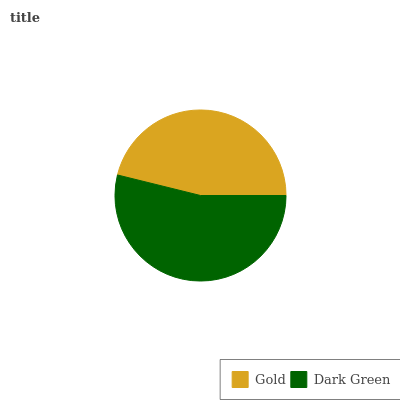Is Gold the minimum?
Answer yes or no. Yes. Is Dark Green the maximum?
Answer yes or no. Yes. Is Dark Green the minimum?
Answer yes or no. No. Is Dark Green greater than Gold?
Answer yes or no. Yes. Is Gold less than Dark Green?
Answer yes or no. Yes. Is Gold greater than Dark Green?
Answer yes or no. No. Is Dark Green less than Gold?
Answer yes or no. No. Is Dark Green the high median?
Answer yes or no. Yes. Is Gold the low median?
Answer yes or no. Yes. Is Gold the high median?
Answer yes or no. No. Is Dark Green the low median?
Answer yes or no. No. 